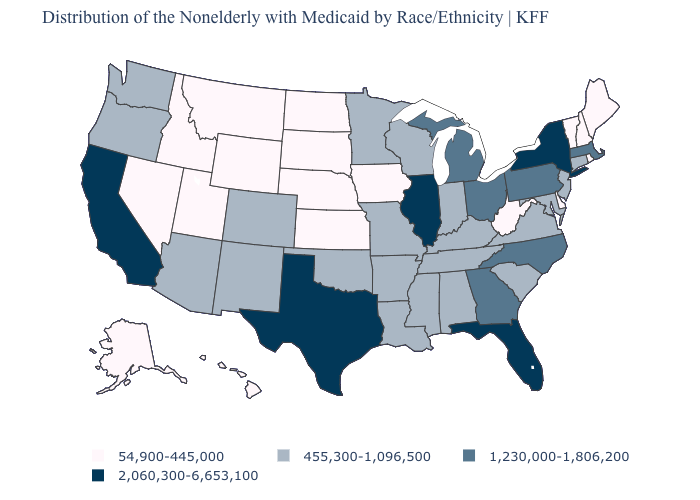What is the value of Arkansas?
Be succinct. 455,300-1,096,500. Does the first symbol in the legend represent the smallest category?
Keep it brief. Yes. Does the map have missing data?
Give a very brief answer. No. How many symbols are there in the legend?
Write a very short answer. 4. What is the value of North Carolina?
Short answer required. 1,230,000-1,806,200. Among the states that border Utah , does Wyoming have the lowest value?
Short answer required. Yes. Name the states that have a value in the range 2,060,300-6,653,100?
Be succinct. California, Florida, Illinois, New York, Texas. What is the value of Mississippi?
Short answer required. 455,300-1,096,500. What is the value of Massachusetts?
Concise answer only. 1,230,000-1,806,200. Name the states that have a value in the range 1,230,000-1,806,200?
Concise answer only. Georgia, Massachusetts, Michigan, North Carolina, Ohio, Pennsylvania. Name the states that have a value in the range 54,900-445,000?
Answer briefly. Alaska, Delaware, Hawaii, Idaho, Iowa, Kansas, Maine, Montana, Nebraska, Nevada, New Hampshire, North Dakota, Rhode Island, South Dakota, Utah, Vermont, West Virginia, Wyoming. Does the first symbol in the legend represent the smallest category?
Short answer required. Yes. Which states have the lowest value in the USA?
Keep it brief. Alaska, Delaware, Hawaii, Idaho, Iowa, Kansas, Maine, Montana, Nebraska, Nevada, New Hampshire, North Dakota, Rhode Island, South Dakota, Utah, Vermont, West Virginia, Wyoming. Which states have the lowest value in the Northeast?
Give a very brief answer. Maine, New Hampshire, Rhode Island, Vermont. Which states have the highest value in the USA?
Answer briefly. California, Florida, Illinois, New York, Texas. 